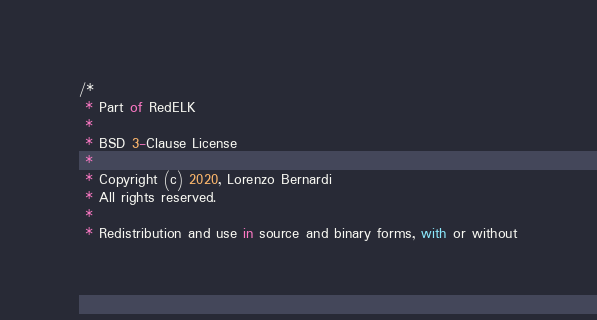Convert code to text. <code><loc_0><loc_0><loc_500><loc_500><_TypeScript_>/*
 * Part of RedELK
 *
 * BSD 3-Clause License
 *
 * Copyright (c) 2020, Lorenzo Bernardi
 * All rights reserved.
 *
 * Redistribution and use in source and binary forms, with or without</code> 